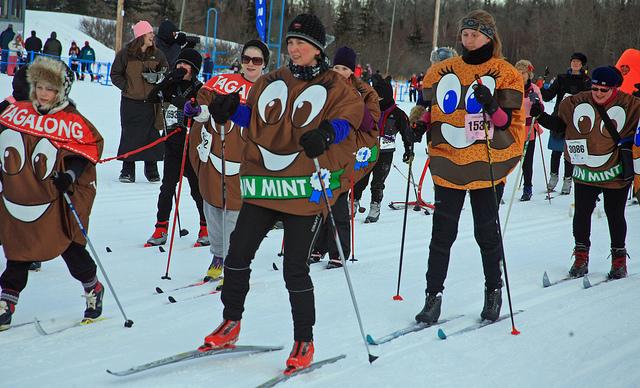Are these people in a sport?
Quick response, please. Yes. Are the any animals?
Write a very short answer. No. What organization sells these types of cookies?
Write a very short answer. Girl scouts. Is this a summer scene?
Give a very brief answer. No. 